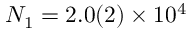Convert formula to latex. <formula><loc_0><loc_0><loc_500><loc_500>N _ { 1 } = 2 . 0 ( 2 ) \times 1 0 ^ { 4 }</formula> 